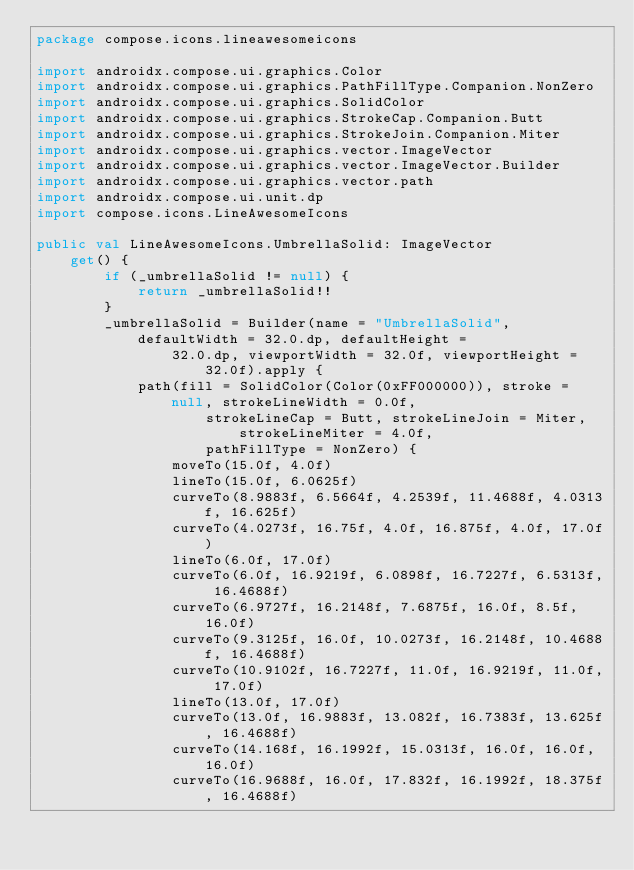<code> <loc_0><loc_0><loc_500><loc_500><_Kotlin_>package compose.icons.lineawesomeicons

import androidx.compose.ui.graphics.Color
import androidx.compose.ui.graphics.PathFillType.Companion.NonZero
import androidx.compose.ui.graphics.SolidColor
import androidx.compose.ui.graphics.StrokeCap.Companion.Butt
import androidx.compose.ui.graphics.StrokeJoin.Companion.Miter
import androidx.compose.ui.graphics.vector.ImageVector
import androidx.compose.ui.graphics.vector.ImageVector.Builder
import androidx.compose.ui.graphics.vector.path
import androidx.compose.ui.unit.dp
import compose.icons.LineAwesomeIcons

public val LineAwesomeIcons.UmbrellaSolid: ImageVector
    get() {
        if (_umbrellaSolid != null) {
            return _umbrellaSolid!!
        }
        _umbrellaSolid = Builder(name = "UmbrellaSolid", defaultWidth = 32.0.dp, defaultHeight =
                32.0.dp, viewportWidth = 32.0f, viewportHeight = 32.0f).apply {
            path(fill = SolidColor(Color(0xFF000000)), stroke = null, strokeLineWidth = 0.0f,
                    strokeLineCap = Butt, strokeLineJoin = Miter, strokeLineMiter = 4.0f,
                    pathFillType = NonZero) {
                moveTo(15.0f, 4.0f)
                lineTo(15.0f, 6.0625f)
                curveTo(8.9883f, 6.5664f, 4.2539f, 11.4688f, 4.0313f, 16.625f)
                curveTo(4.0273f, 16.75f, 4.0f, 16.875f, 4.0f, 17.0f)
                lineTo(6.0f, 17.0f)
                curveTo(6.0f, 16.9219f, 6.0898f, 16.7227f, 6.5313f, 16.4688f)
                curveTo(6.9727f, 16.2148f, 7.6875f, 16.0f, 8.5f, 16.0f)
                curveTo(9.3125f, 16.0f, 10.0273f, 16.2148f, 10.4688f, 16.4688f)
                curveTo(10.9102f, 16.7227f, 11.0f, 16.9219f, 11.0f, 17.0f)
                lineTo(13.0f, 17.0f)
                curveTo(13.0f, 16.9883f, 13.082f, 16.7383f, 13.625f, 16.4688f)
                curveTo(14.168f, 16.1992f, 15.0313f, 16.0f, 16.0f, 16.0f)
                curveTo(16.9688f, 16.0f, 17.832f, 16.1992f, 18.375f, 16.4688f)</code> 